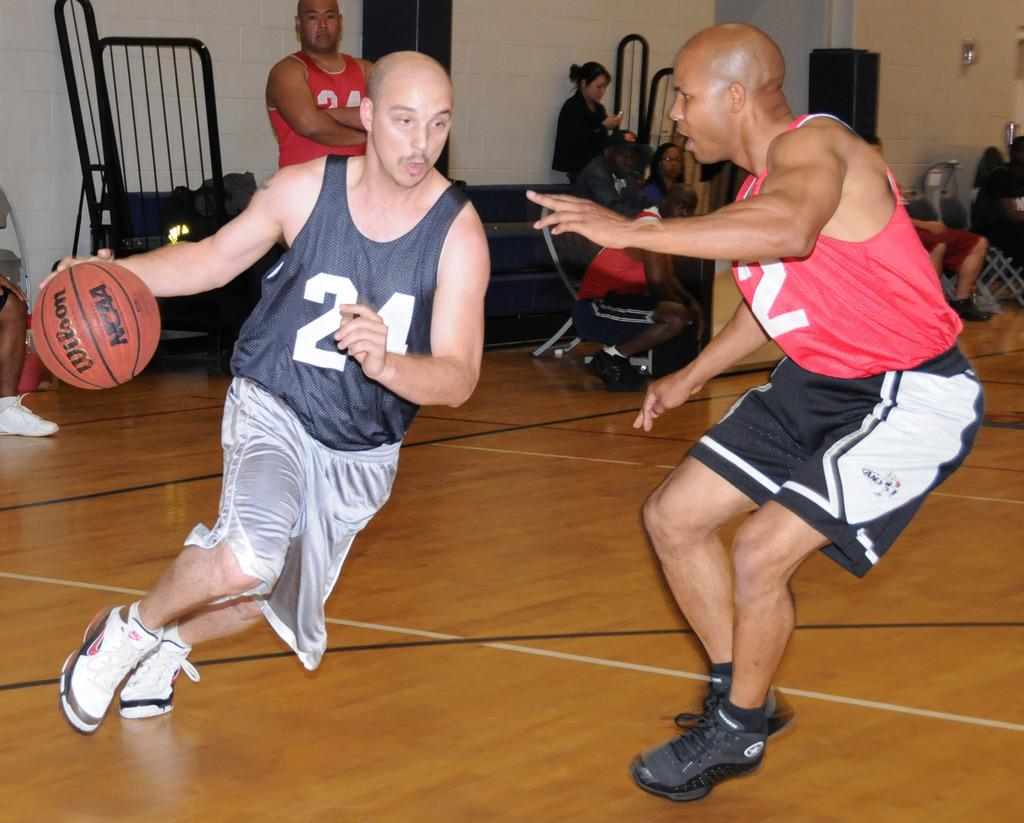<image>
Describe the image concisely. a person dribbling a ball with the number 24 on 